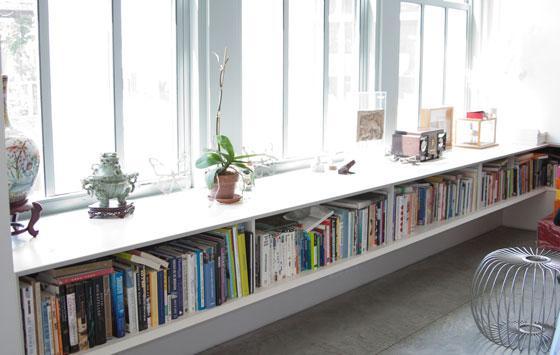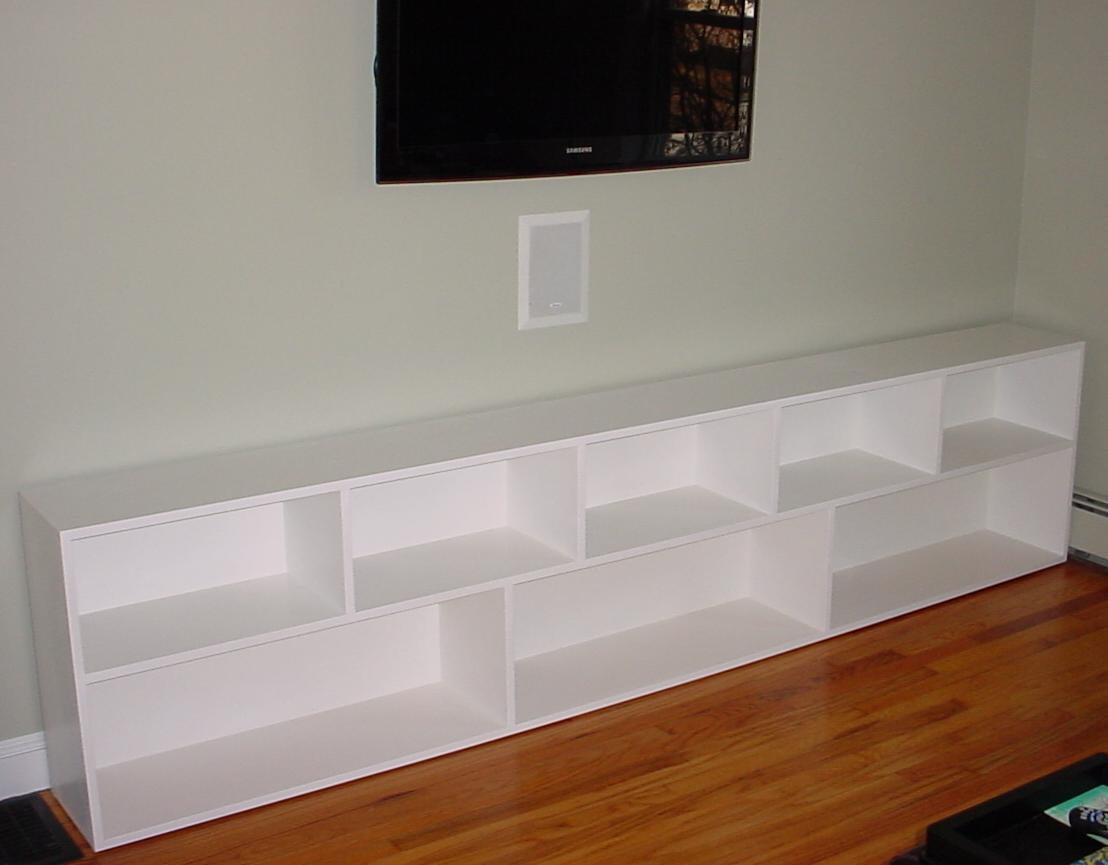The first image is the image on the left, the second image is the image on the right. Examine the images to the left and right. Is the description "An image includes an empty white shelf unit with two layers of staggered compartments." accurate? Answer yes or no. Yes. The first image is the image on the left, the second image is the image on the right. Analyze the images presented: Is the assertion "All of the bookshelves are empty." valid? Answer yes or no. No. 